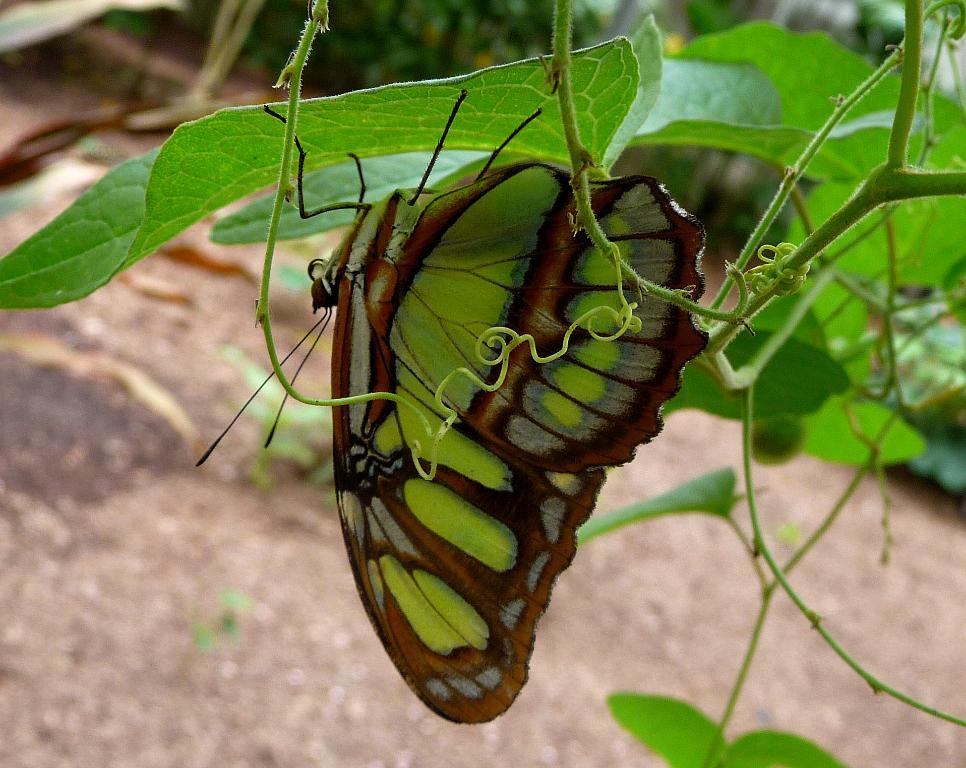What is the main subject of the image? There is a butterfly in the image. Where is the butterfly located? The butterfly is on a leaf. What type of surface can be seen in the image? There is ground visible in the image. What type of pest can be seen attacking the butterfly in the image? There is no pest attacking the butterfly in the image; the butterfly is simply resting on a leaf. What type of farming equipment is present in the image? There is no farming equipment, such as a plough, present in the image. 